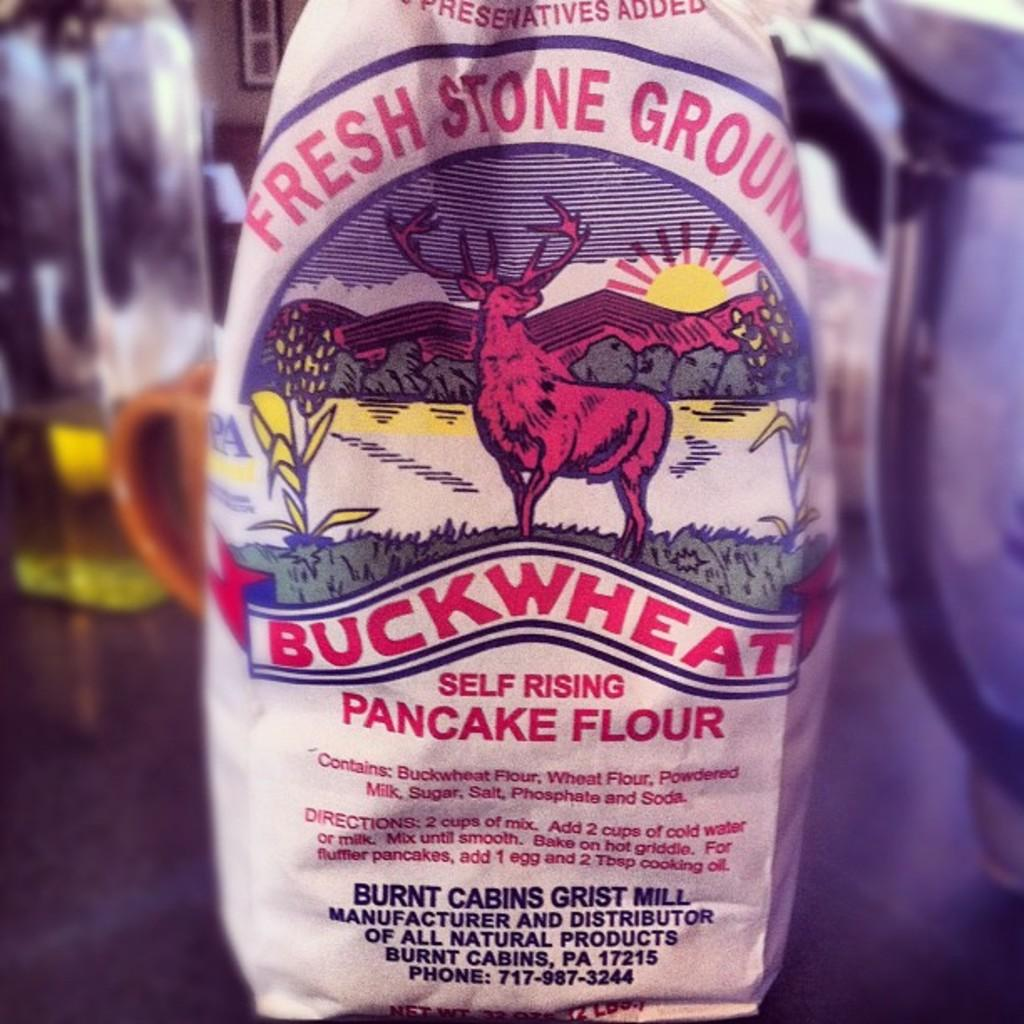What is the name of the bottle in the center of the image? The bottle in the center of the image is named "Fresh Stone Ground." What can be seen in the background of the image? There is a wall, another bottle, and a mug in the background of the image. Can you see a pig using a rake on its toe in the image? No, there is no pig or rake present in the image, and no mention of a toe. 